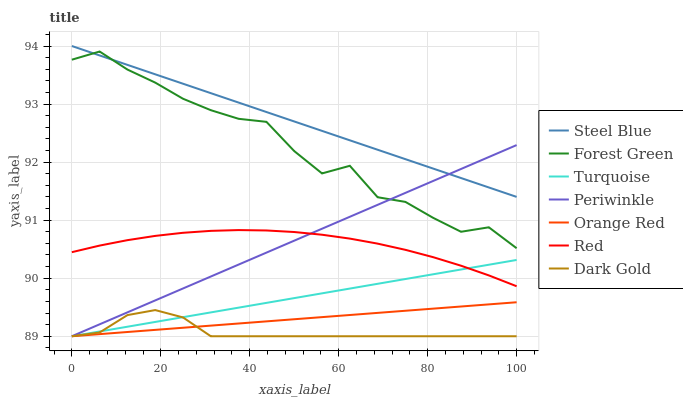Does Dark Gold have the minimum area under the curve?
Answer yes or no. Yes. Does Steel Blue have the maximum area under the curve?
Answer yes or no. Yes. Does Steel Blue have the minimum area under the curve?
Answer yes or no. No. Does Dark Gold have the maximum area under the curve?
Answer yes or no. No. Is Orange Red the smoothest?
Answer yes or no. Yes. Is Forest Green the roughest?
Answer yes or no. Yes. Is Dark Gold the smoothest?
Answer yes or no. No. Is Dark Gold the roughest?
Answer yes or no. No. Does Steel Blue have the lowest value?
Answer yes or no. No. Does Dark Gold have the highest value?
Answer yes or no. No. Is Turquoise less than Forest Green?
Answer yes or no. Yes. Is Steel Blue greater than Orange Red?
Answer yes or no. Yes. Does Turquoise intersect Forest Green?
Answer yes or no. No. 